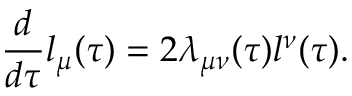<formula> <loc_0><loc_0><loc_500><loc_500>\frac { d } { d \tau } l _ { \mu } ( \tau ) = 2 \lambda _ { \mu \nu } ( \tau ) l ^ { \nu } ( \tau ) .</formula> 